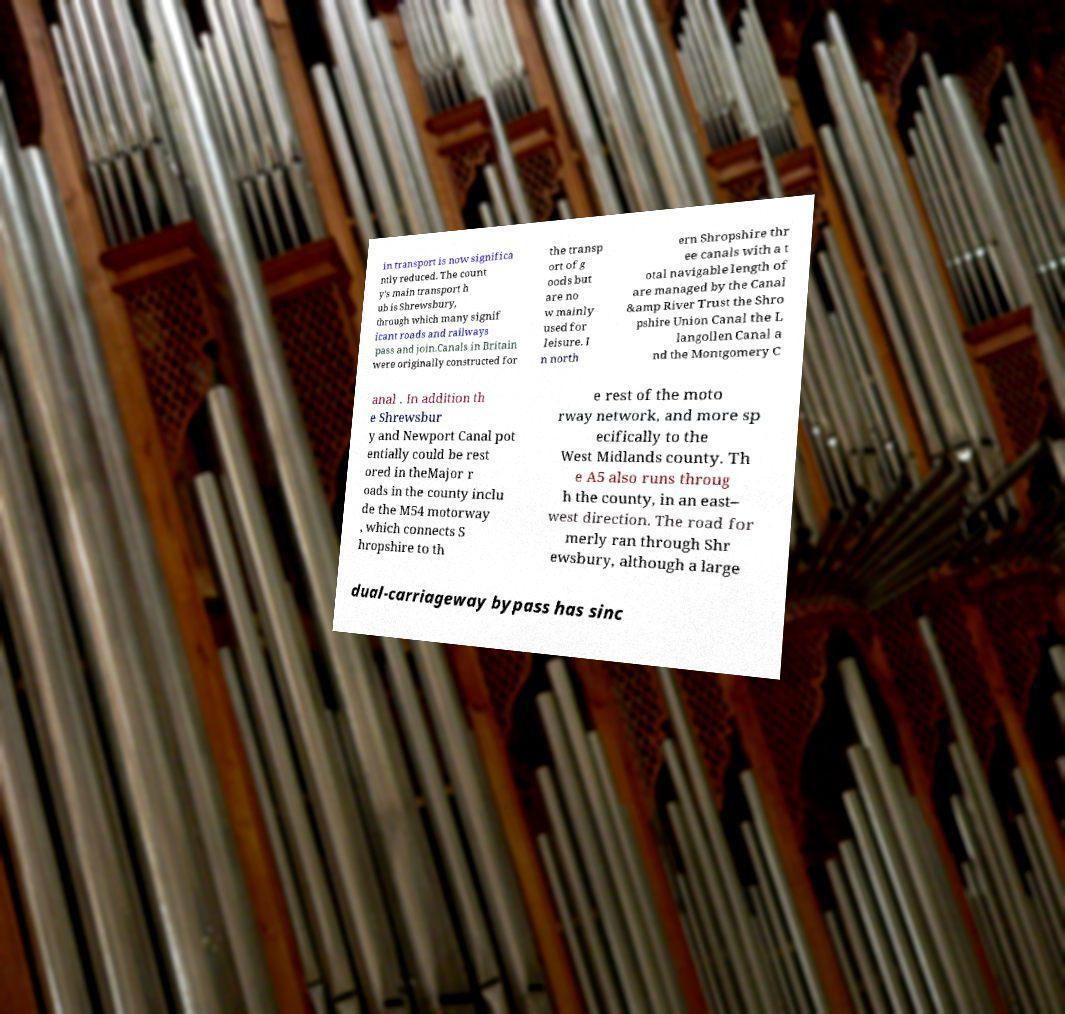For documentation purposes, I need the text within this image transcribed. Could you provide that? in transport is now significa ntly reduced. The count y's main transport h ub is Shrewsbury, through which many signif icant roads and railways pass and join.Canals in Britain were originally constructed for the transp ort of g oods but are no w mainly used for leisure. I n north ern Shropshire thr ee canals with a t otal navigable length of are managed by the Canal &amp River Trust the Shro pshire Union Canal the L langollen Canal a nd the Montgomery C anal . In addition th e Shrewsbur y and Newport Canal pot entially could be rest ored in theMajor r oads in the county inclu de the M54 motorway , which connects S hropshire to th e rest of the moto rway network, and more sp ecifically to the West Midlands county. Th e A5 also runs throug h the county, in an east– west direction. The road for merly ran through Shr ewsbury, although a large dual-carriageway bypass has sinc 